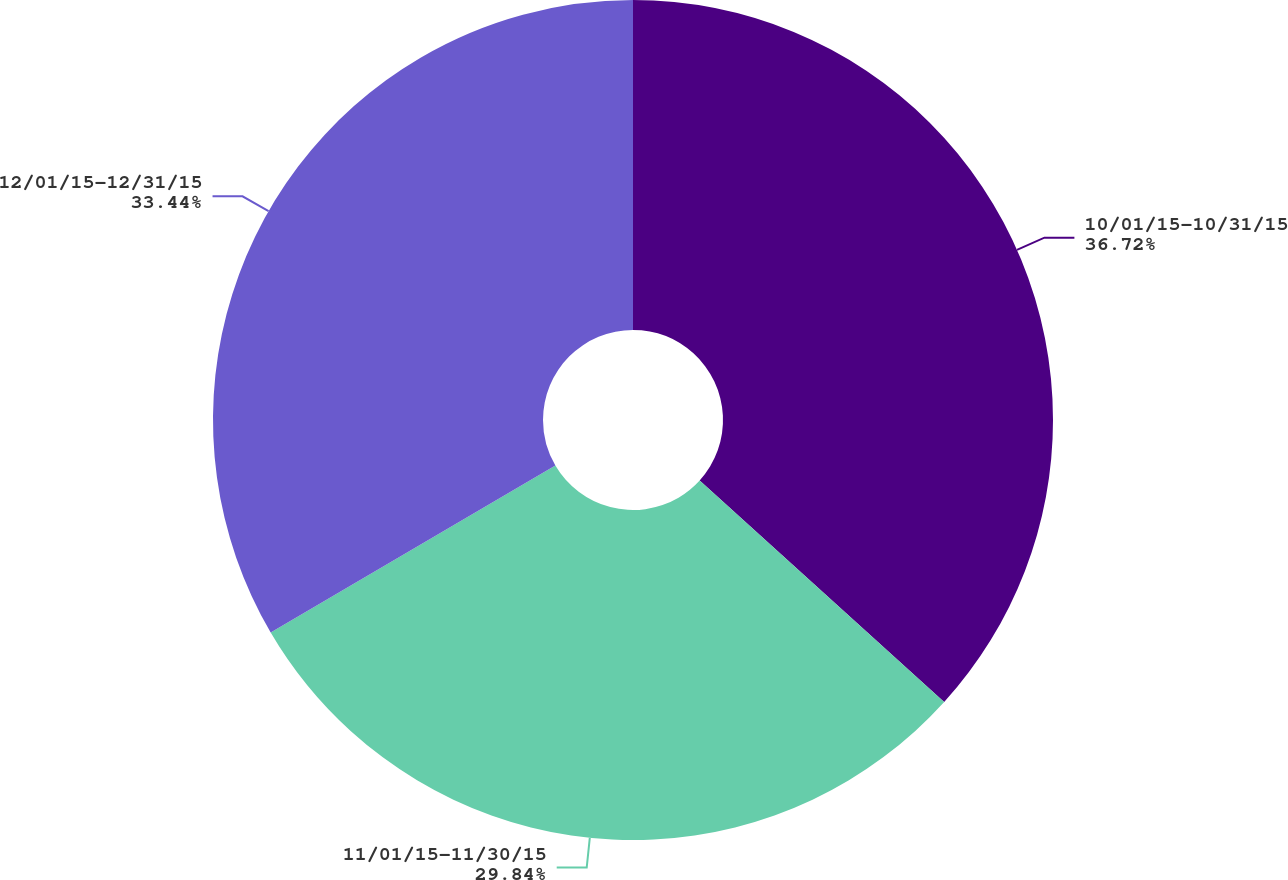Convert chart. <chart><loc_0><loc_0><loc_500><loc_500><pie_chart><fcel>10/01/15-10/31/15<fcel>11/01/15-11/30/15<fcel>12/01/15-12/31/15<nl><fcel>36.72%<fcel>29.84%<fcel>33.44%<nl></chart> 